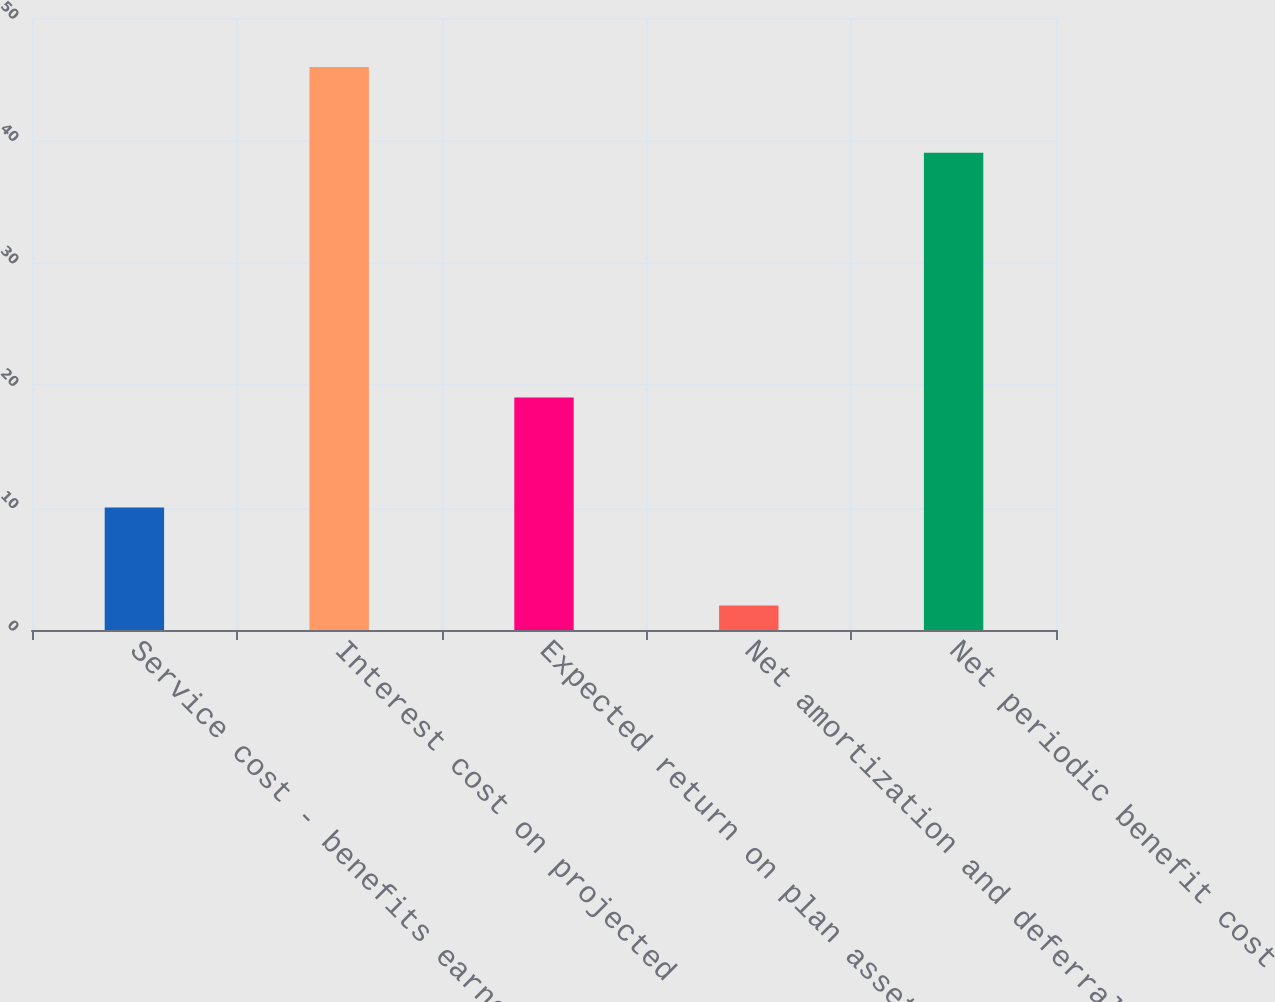Convert chart. <chart><loc_0><loc_0><loc_500><loc_500><bar_chart><fcel>Service cost - benefits earned<fcel>Interest cost on projected<fcel>Expected return on plan assets<fcel>Net amortization and deferral<fcel>Net periodic benefit cost<nl><fcel>10<fcel>46<fcel>19<fcel>2<fcel>39<nl></chart> 